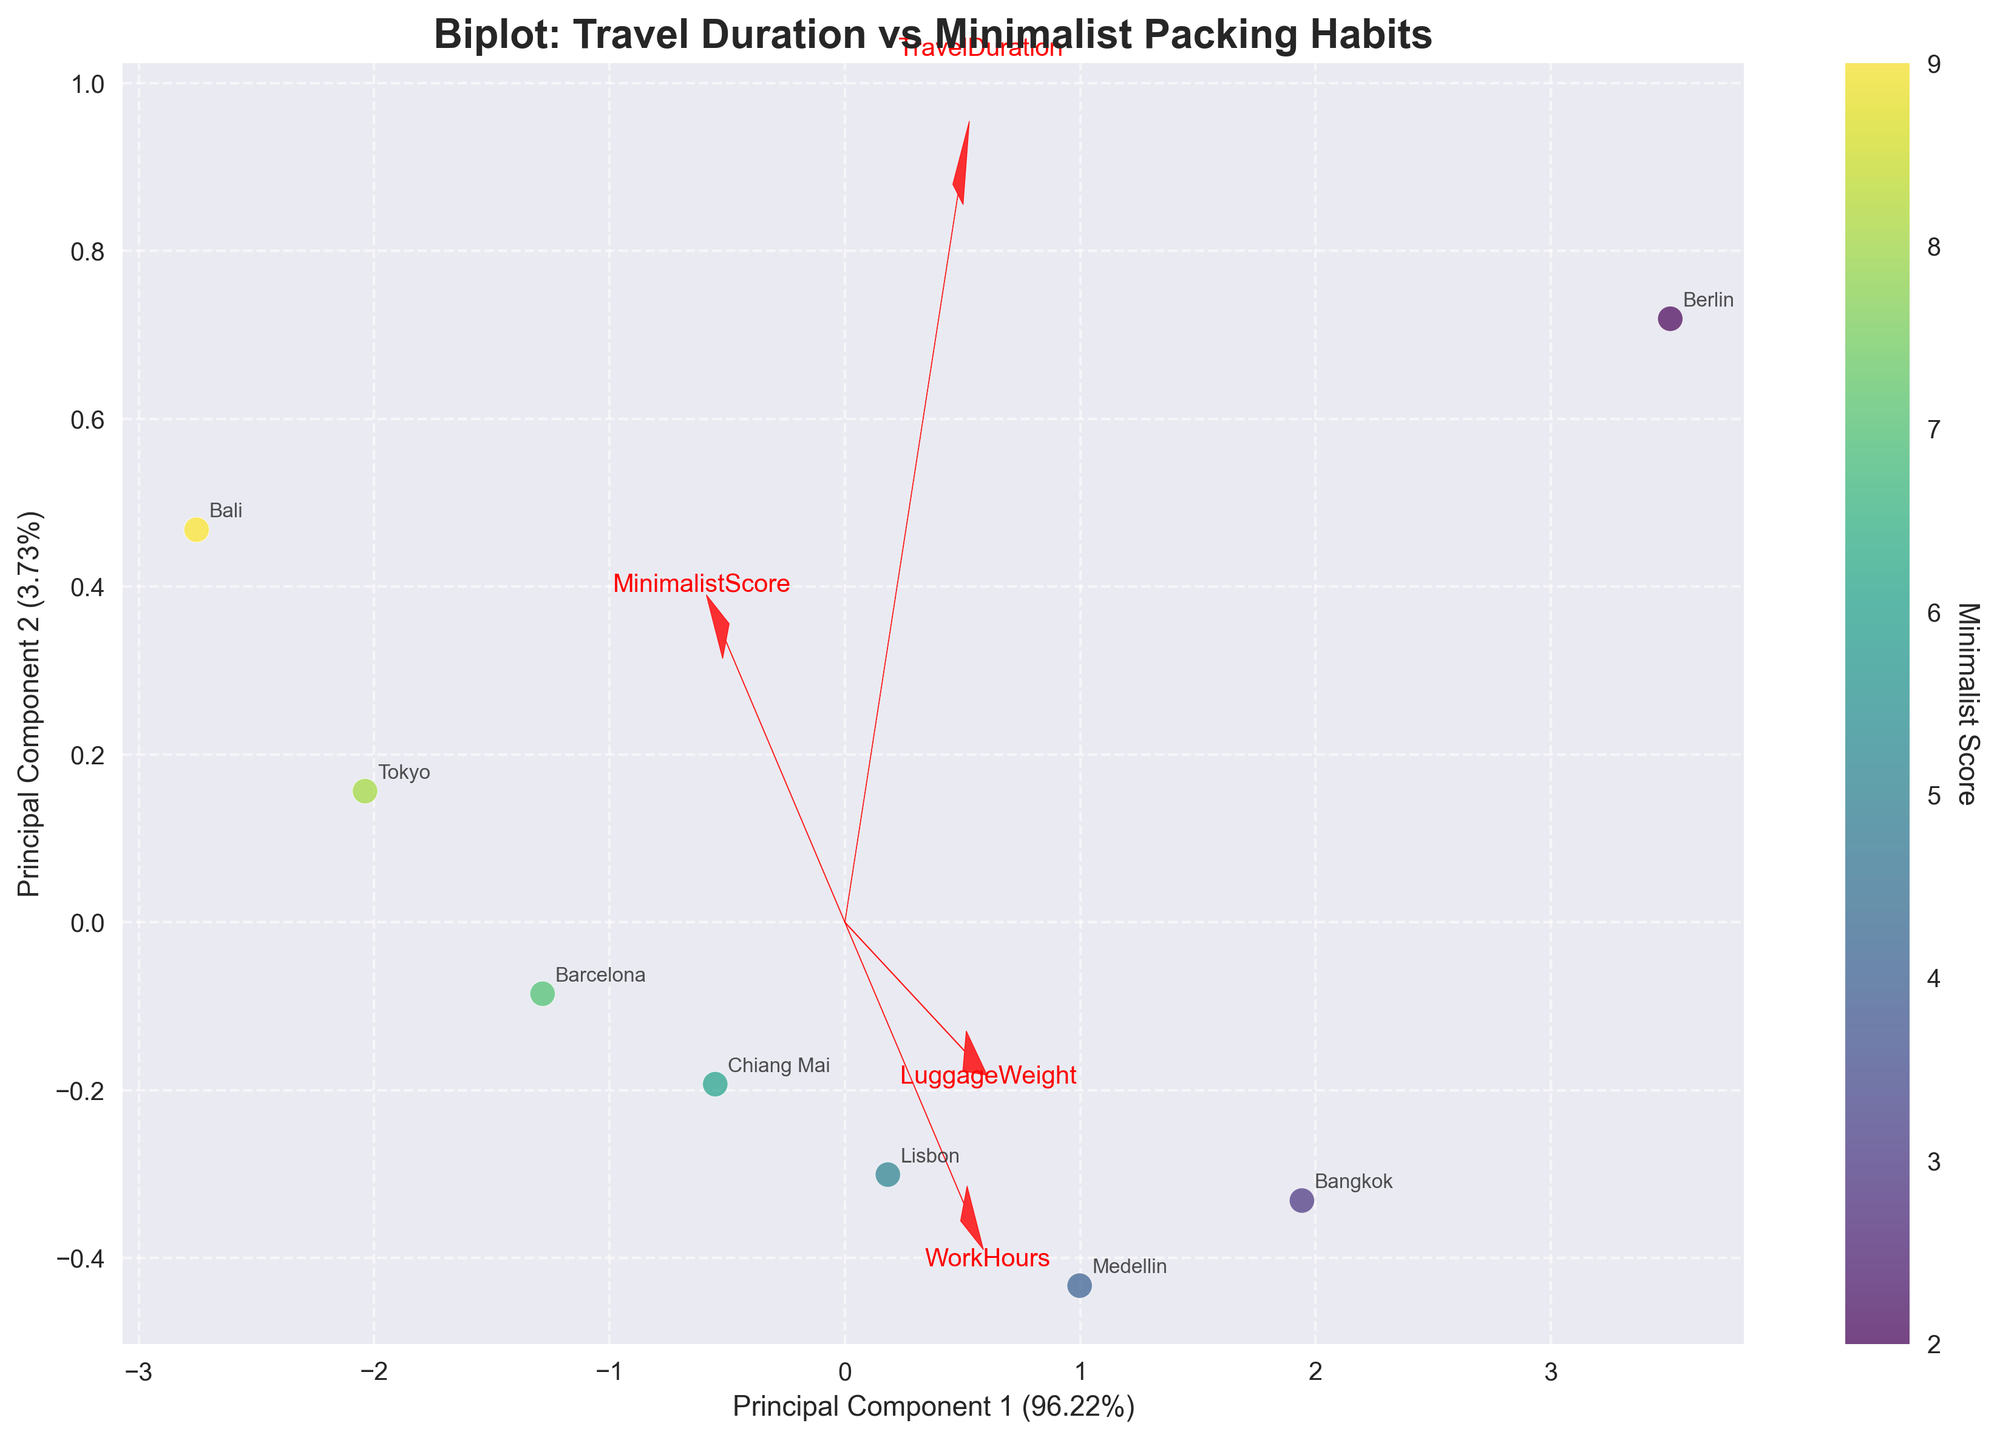What are the axes labeled as? The x-axis is labeled as "Principal Component 1" and the y-axis is labeled as "Principal Component 2". These labels indicate that the axes represent the first two principal components from PCA, with their respective explained variance percentages.
Answer: Principal Component 1 and Principal Component 2 How many destinations are represented in the plot? By counting the number of unique destination labels annotated on the plot, we can identify that there are 8 destinations in total. Each annotated point represents a different destination.
Answer: 8 Which feature has the most significant contribution to Principal Component 1? By observing the direction and length of the feature vectors from the origin, the feature 'TravelDuration' has the longest vector along Principal Component 1, indicating it has the most significant contribution to it.
Answer: TravelDuration Which destination has the highest MinimalistScore? The colorbar labels indicate that darker colors correspond to lower MinimalistScores. By looking for the lightest colored point, 'Bali' has the lightest color, indicating the highest MinimalistScore of 9.
Answer: Bali What is the relationship between TravelDuration and LuggageWeight according to the feature vectors? The feature vectors for TravelDuration and LuggageWeight point in almost the same direction, indicating a positive correlation. This suggests that as TravelDuration increases, LuggageWeight also tends to increase.
Answer: Positive correlation Which accommodation type is associated with the highest number of work hours? By identifying the position and annotation of the point that is furthest in the direction of the 'WorkHours' vector, we see that 'Berlin' (Flat share) lies in that region, so it is associated with the highest number of work hours.
Answer: Flat share Which feature contributes the least to Principal Component 2? By observing the feature vectors and their orientation with respect to Principal Component 2, the vector for the 'WorkHours' feature is the shortest and closest to perpendicular to this axis, meaning it contributes the least to Principal Component 2.
Answer: WorkHours Which destination appears to have the longest travel duration? The point for 'Berlin' is furthest in the direction of the 'TravelDuration' vector, indicating it has the longest travel duration (365 days).
Answer: Berlin How does the MinimalistScore change with increasing travel duration? Most points with higher travel duration (like 'Berlin,' 'Bangkok,' 'Medellin') have darker colors, which correlate to lower MinimalistScores. This implies that the MinimalistScore tends to decrease with increasing travel duration.
Answer: Decreases What can be inferred about the accommodation types for shorter travel durations? By examining points with shorter travel durations (like 'Bali,' 'Tokyo'), they are associated with accommodations like 'Hostel' and 'Airbnb,' suggesting that nomads with shorter travel durations tend to stay in these types of accommodations.
Answer: Hostel and Airbnb 